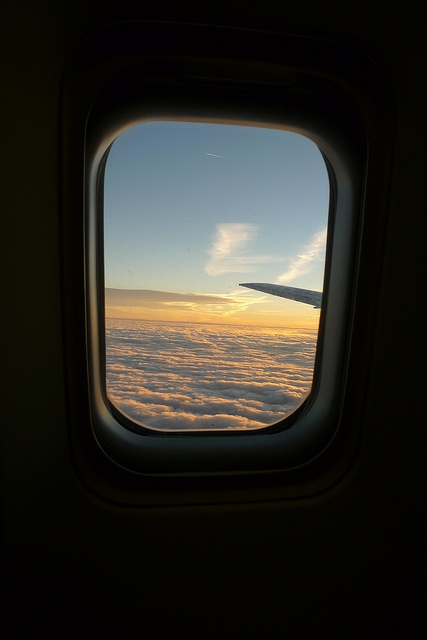Describe the objects in this image and their specific colors. I can see a airplane in black, gray, khaki, darkgray, and beige tones in this image. 